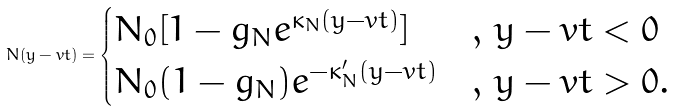Convert formula to latex. <formula><loc_0><loc_0><loc_500><loc_500>N ( y - v t ) = \begin{cases} N _ { 0 } [ 1 - g _ { N } e ^ { \kappa _ { N } ( y - v t ) } ] & , \, y - v t < 0 \\ N _ { 0 } ( 1 - g _ { N } ) e ^ { - \kappa ^ { \prime } _ { N } ( y - v t ) } & , \, y - v t > 0 . \end{cases}</formula> 